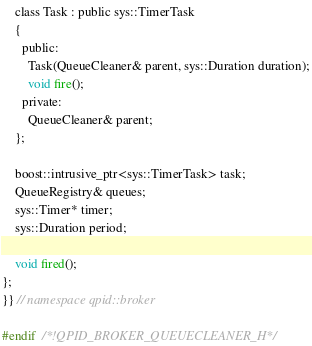Convert code to text. <code><loc_0><loc_0><loc_500><loc_500><_C_>    class Task : public sys::TimerTask
    {
      public:
        Task(QueueCleaner& parent, sys::Duration duration);
        void fire();
      private:
        QueueCleaner& parent;
    };

    boost::intrusive_ptr<sys::TimerTask> task;
    QueueRegistry& queues;
    sys::Timer* timer;
    sys::Duration period;

    void fired();
};
}} // namespace qpid::broker

#endif  /*!QPID_BROKER_QUEUECLEANER_H*/
</code> 